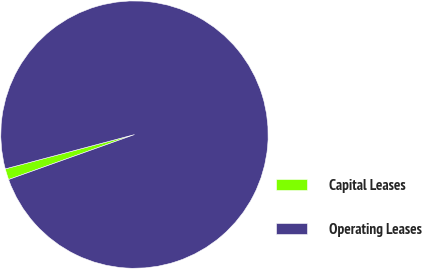Convert chart to OTSL. <chart><loc_0><loc_0><loc_500><loc_500><pie_chart><fcel>Capital Leases<fcel>Operating Leases<nl><fcel>1.33%<fcel>98.67%<nl></chart> 